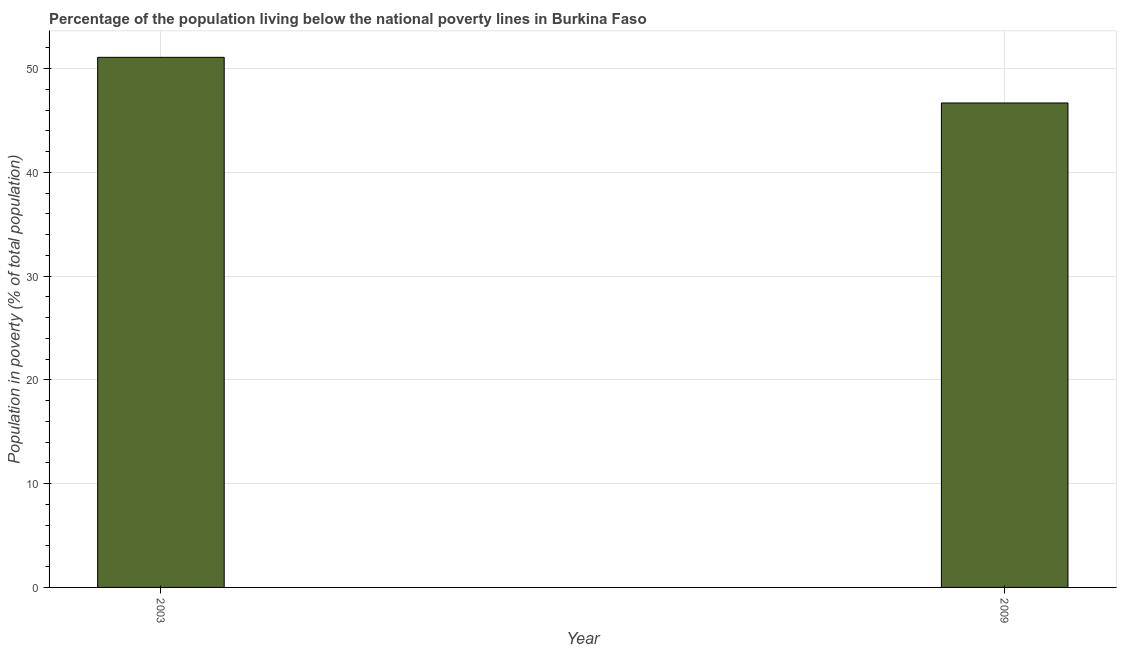Does the graph contain any zero values?
Keep it short and to the point. No. Does the graph contain grids?
Offer a terse response. Yes. What is the title of the graph?
Offer a very short reply. Percentage of the population living below the national poverty lines in Burkina Faso. What is the label or title of the X-axis?
Provide a succinct answer. Year. What is the label or title of the Y-axis?
Provide a succinct answer. Population in poverty (% of total population). What is the percentage of population living below poverty line in 2003?
Offer a terse response. 51.1. Across all years, what is the maximum percentage of population living below poverty line?
Your answer should be compact. 51.1. Across all years, what is the minimum percentage of population living below poverty line?
Provide a succinct answer. 46.7. In which year was the percentage of population living below poverty line maximum?
Your answer should be very brief. 2003. In which year was the percentage of population living below poverty line minimum?
Offer a terse response. 2009. What is the sum of the percentage of population living below poverty line?
Your answer should be very brief. 97.8. What is the difference between the percentage of population living below poverty line in 2003 and 2009?
Provide a succinct answer. 4.4. What is the average percentage of population living below poverty line per year?
Make the answer very short. 48.9. What is the median percentage of population living below poverty line?
Ensure brevity in your answer.  48.9. Do a majority of the years between 2003 and 2009 (inclusive) have percentage of population living below poverty line greater than 50 %?
Your answer should be very brief. No. What is the ratio of the percentage of population living below poverty line in 2003 to that in 2009?
Provide a short and direct response. 1.09. Is the percentage of population living below poverty line in 2003 less than that in 2009?
Your answer should be compact. No. How many bars are there?
Give a very brief answer. 2. How many years are there in the graph?
Your answer should be very brief. 2. Are the values on the major ticks of Y-axis written in scientific E-notation?
Keep it short and to the point. No. What is the Population in poverty (% of total population) of 2003?
Make the answer very short. 51.1. What is the Population in poverty (% of total population) of 2009?
Give a very brief answer. 46.7. What is the ratio of the Population in poverty (% of total population) in 2003 to that in 2009?
Your response must be concise. 1.09. 